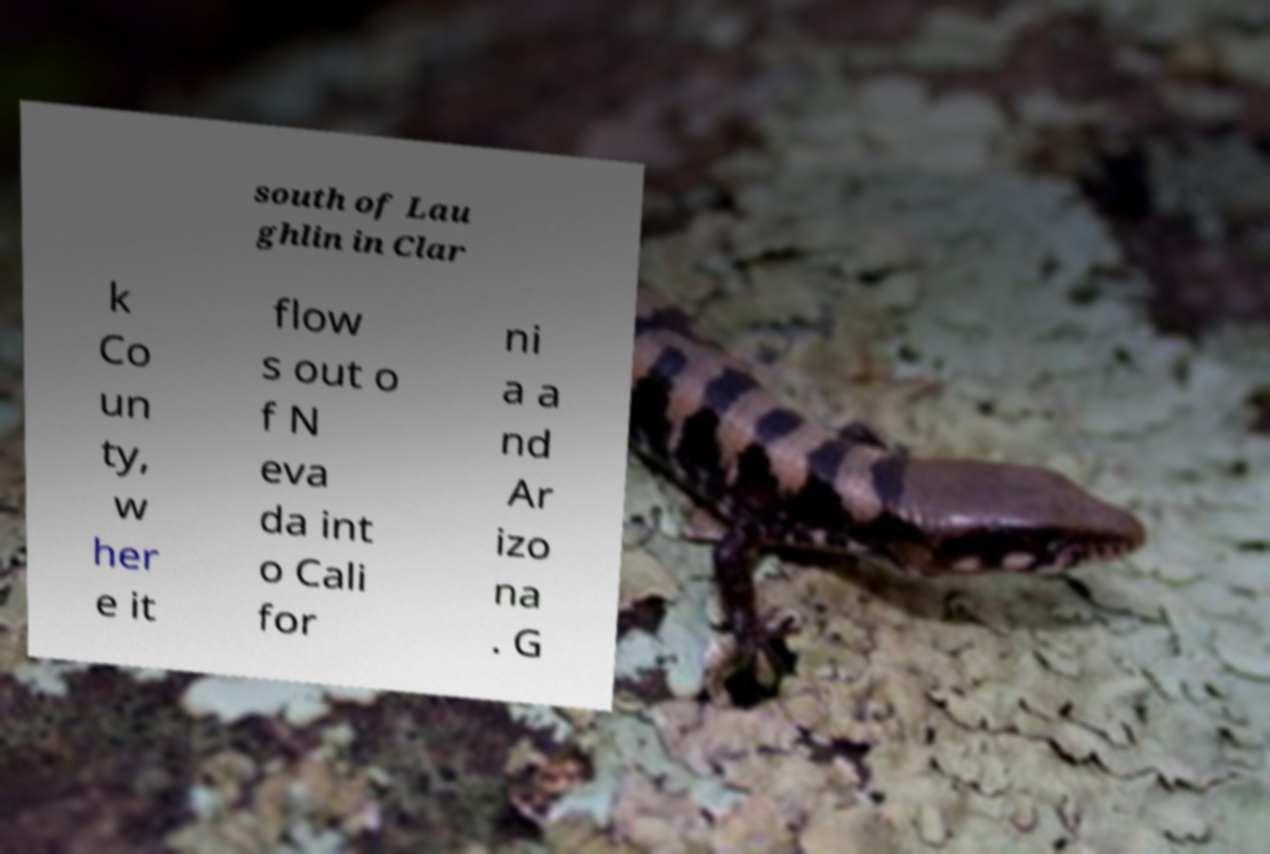What messages or text are displayed in this image? I need them in a readable, typed format. south of Lau ghlin in Clar k Co un ty, w her e it flow s out o f N eva da int o Cali for ni a a nd Ar izo na . G 